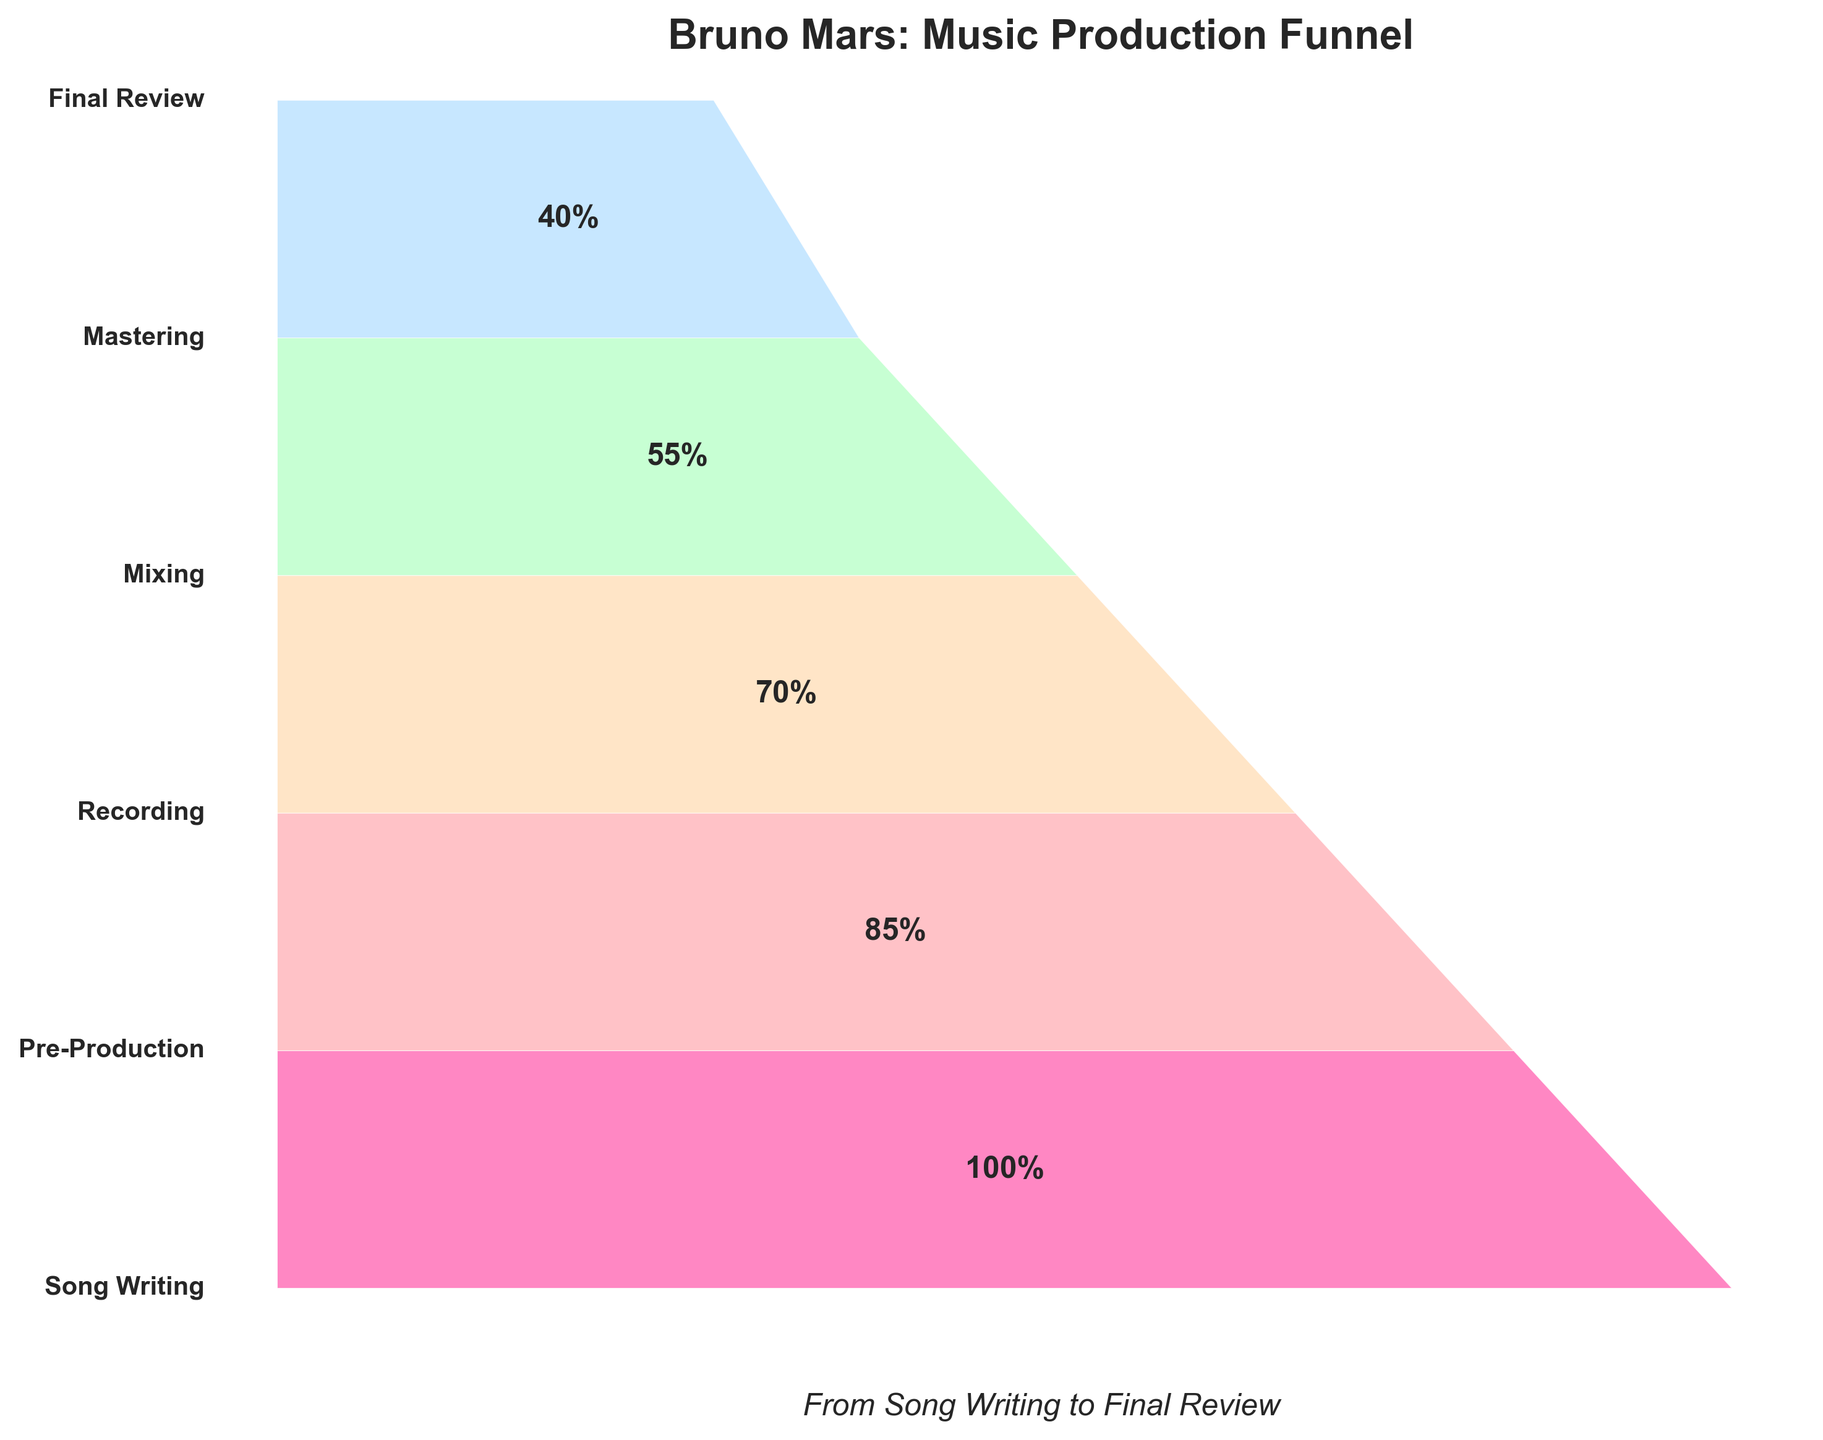What is the title of the funnel chart? The title is located at the top of the figure and reads "Bruno Mars: Music Production Funnel".
Answer: Bruno Mars: Music Production Funnel How many stages are there in the music production process? Count the number of unique stages listed on the left side of the funnel chart.
Answer: 6 stages Which stage has the highest percentage? The stage with the highest percentage can be found at the widest part of the funnel, which is the top of the chart.
Answer: Song Writing What is the percentage at the Mixing stage? Locate the Mixing stage listed on the left side of the chart and read the corresponding percentage in the middle part of the funnel.
Answer: 55% What is the difference in percentage between Recording and Mixing stages? Subtract the percentage at the Mixing stage from the percentage at the Recording stage: 70% (Recording) - 55% (Mixing).
Answer: 15% Which stage marks a decrease to below half of the starting percentage? Find the first stage where the percentage drops below 50% of the initial 100% by checking the left side of the chart sequentially.
Answer: Mixing How much does the percentage decrease from Pre-Production to Mastering? Calculate the difference in percentages: Pre-Production (85%) - Mastering (40%) = 45%.
Answer: 45% Which two stages have the smallest difference in their percentages? Compare percentage differences between consecutive stages to find the smallest one. The smallest difference is between Mastering (40%) and Final Review (30%), which is 10%.
Answer: Mastering and Final Review What is the percentage at the Final Review stage as a fraction of the initial percentage? Divide the percentage at the Final Review stage by the initial percentage: 30% / 100% = 0.30 or 30%.
Answer: 30% By what percentage does the Recording stage outperform the Final Review stage? Subtract the Final Review percentage from the Recording percentage and explain the difference: 70% (Recording) - 30% (Final Review) = 40%.
Answer: 40% 